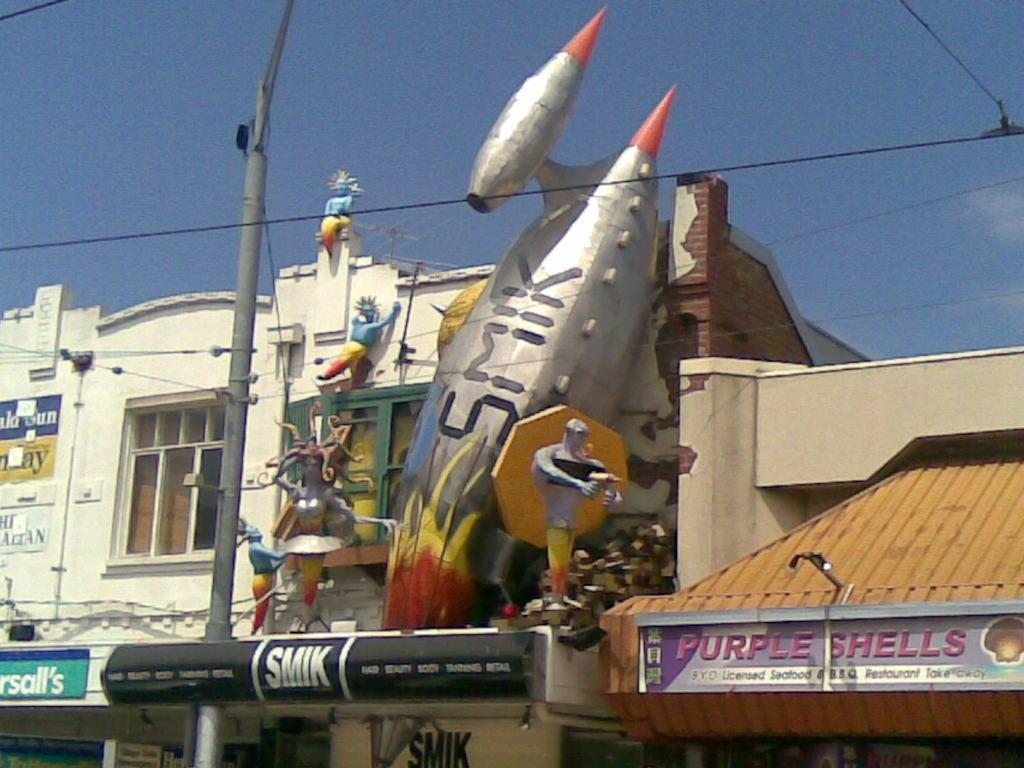What is located in the foreground of the image? There is a pole and buildings in the foreground of the image. What can be seen on one of the buildings? There are sculptures on one of the buildings. What is visible at the top of the image? Cables and the sky are visible at the top of the image. What type of degree is being awarded to the person sitting at the desk in the image? There is no person sitting at a desk in the image, nor is there any mention of a degree being awarded. 